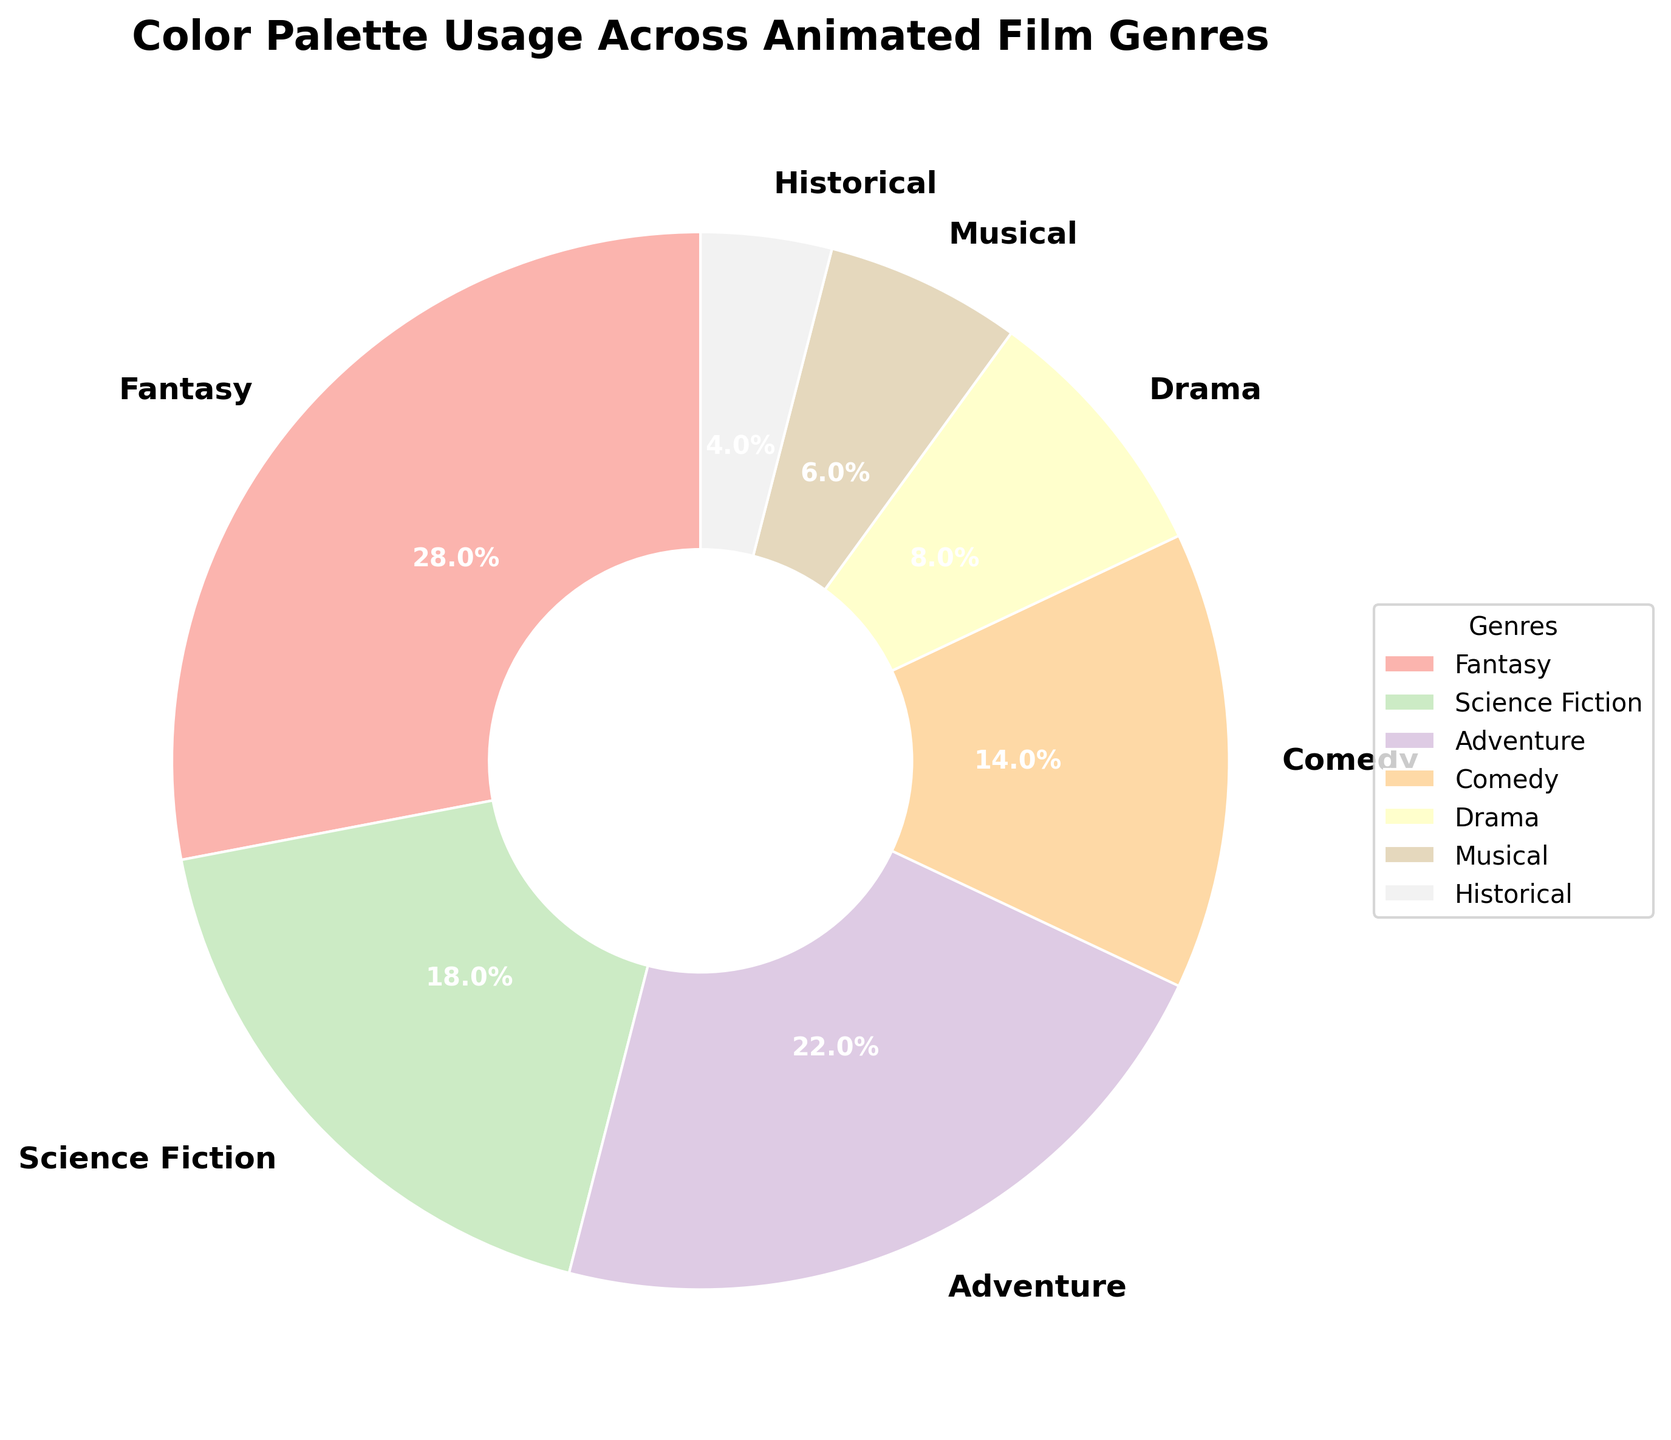What genre has the highest percentage of color palette usage? The segment with the largest size in the pie chart represents the genre with the highest percentage. In this chart, it is the 'Fantasy' segment with a 28% usage.
Answer: Fantasy Which genre has the least color palette usage, and what is its percentage? The smallest segment in the pie chart represents the genre with the least usage. In this chart, 'Historical' has the smallest segment with a 4% usage.
Answer: Historical, 4% Compare the color palette usage between 'Adventure' and 'Comedy'. Looking at the pie chart, the segment for 'Adventure' is larger compared to 'Comedy'. 'Adventure' has a 22% usage, while 'Comedy' has 14%.
Answer: Adventure has 22%, Comedy has 14% What is the combined percentage of color palette usage for 'Science Fiction' and 'Drama'? To find the combined percentage, add the percentages of 'Science Fiction' and 'Drama'. 'Science Fiction' has 18% and 'Drama' has 8%. So, 18% + 8% = 26%.
Answer: 26% Is the percentage of color palette usage in 'Musical' greater than 'Historical'? By how much? 'Musical' has a 6% usage and 'Historical' has a 4% usage. The difference can be calculated as 6% - 4% = 2%.
Answer: Yes, by 2% What is the second most used genre in terms of color palette? After the largest segment, 'Fantasy' at 28%, the next largest segment is 'Adventure' with a 22% usage.
Answer: Adventure Calculate the difference between the percentages of 'Fantasy' and 'Musical'. 'Fantasy' has 28% and 'Musical' has 6%. The difference is 28% - 6% = 22%.
Answer: 22% Find the average color palette usage across all the genres. Sum all the percentages and divide by the number of genres. (28% + 18% + 22% + 14% + 8% + 6% + 4%) / 7 = 100% / 7 ≈ 14.3%.
Answer: Approx. 14.3% Which color-coded segment represents 'Drama' in the visual? The segment representing 'Drama' will typically be labeled 'Drama' and colored in one of the pastel shades. In this pie chart, 'Drama' is represented with a specific light shade closer to the central section.
Answer: Light shade near center, labeled 'Drama' If the 'Comedy' genre had an increase in color palette usage by 4%, what would be its new percentage, and would it surpass 'Adventure'? 'Comedy' currently has 14%. An increase by 4% would make it 14% + 4% = 18%. 'Adventure' has 22%, so 'Comedy' at 18% would not surpass 'Adventure'.
Answer: 18%, no 